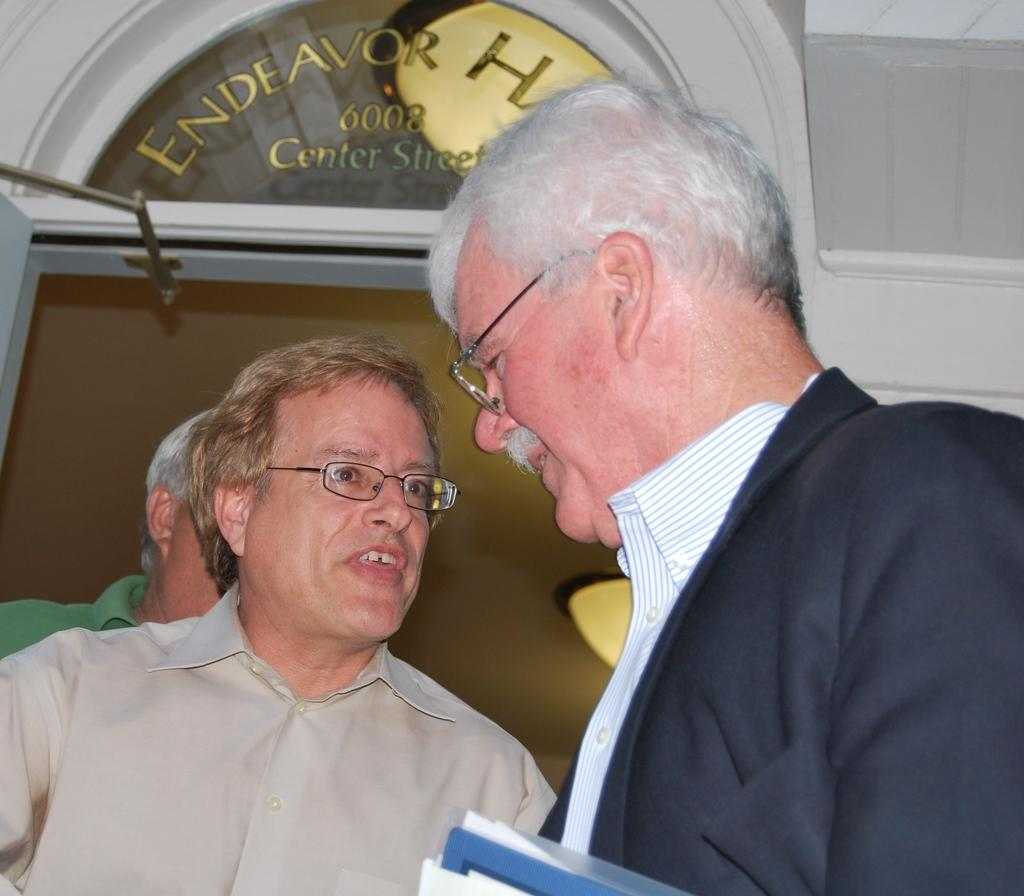How many people are in the image? There are three people in the image. What can be observed about the eyewear of two of the people? Two of the people are wearing spectacles. What is the person on the right side of the image doing? The person on the right side is holding something. Can you describe any text visible in the image? There is text visible on a glass in the background of the image. What type of kettle can be seen in the image? There is no kettle present in the image. Can you describe the cave in the image? There is no cave present in the image. 